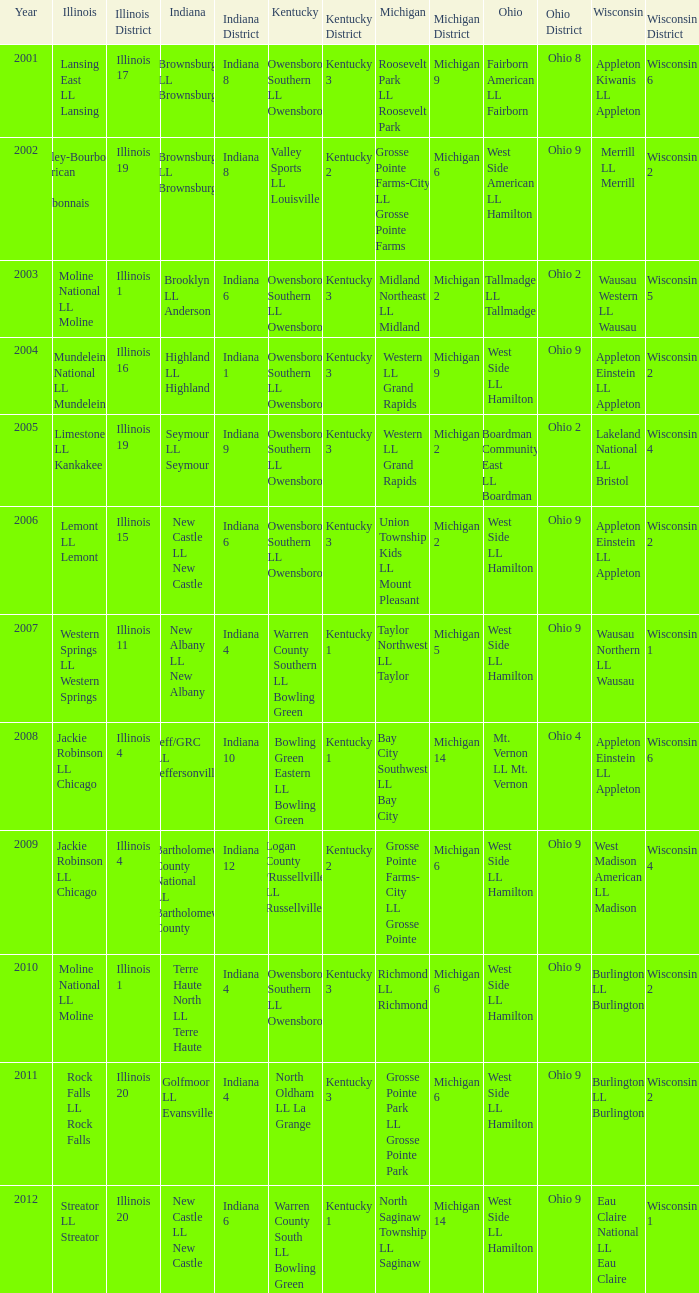What was the little league team from Kentucky when the little league team from Illinois was Rock Falls LL Rock Falls? North Oldham LL La Grange. 